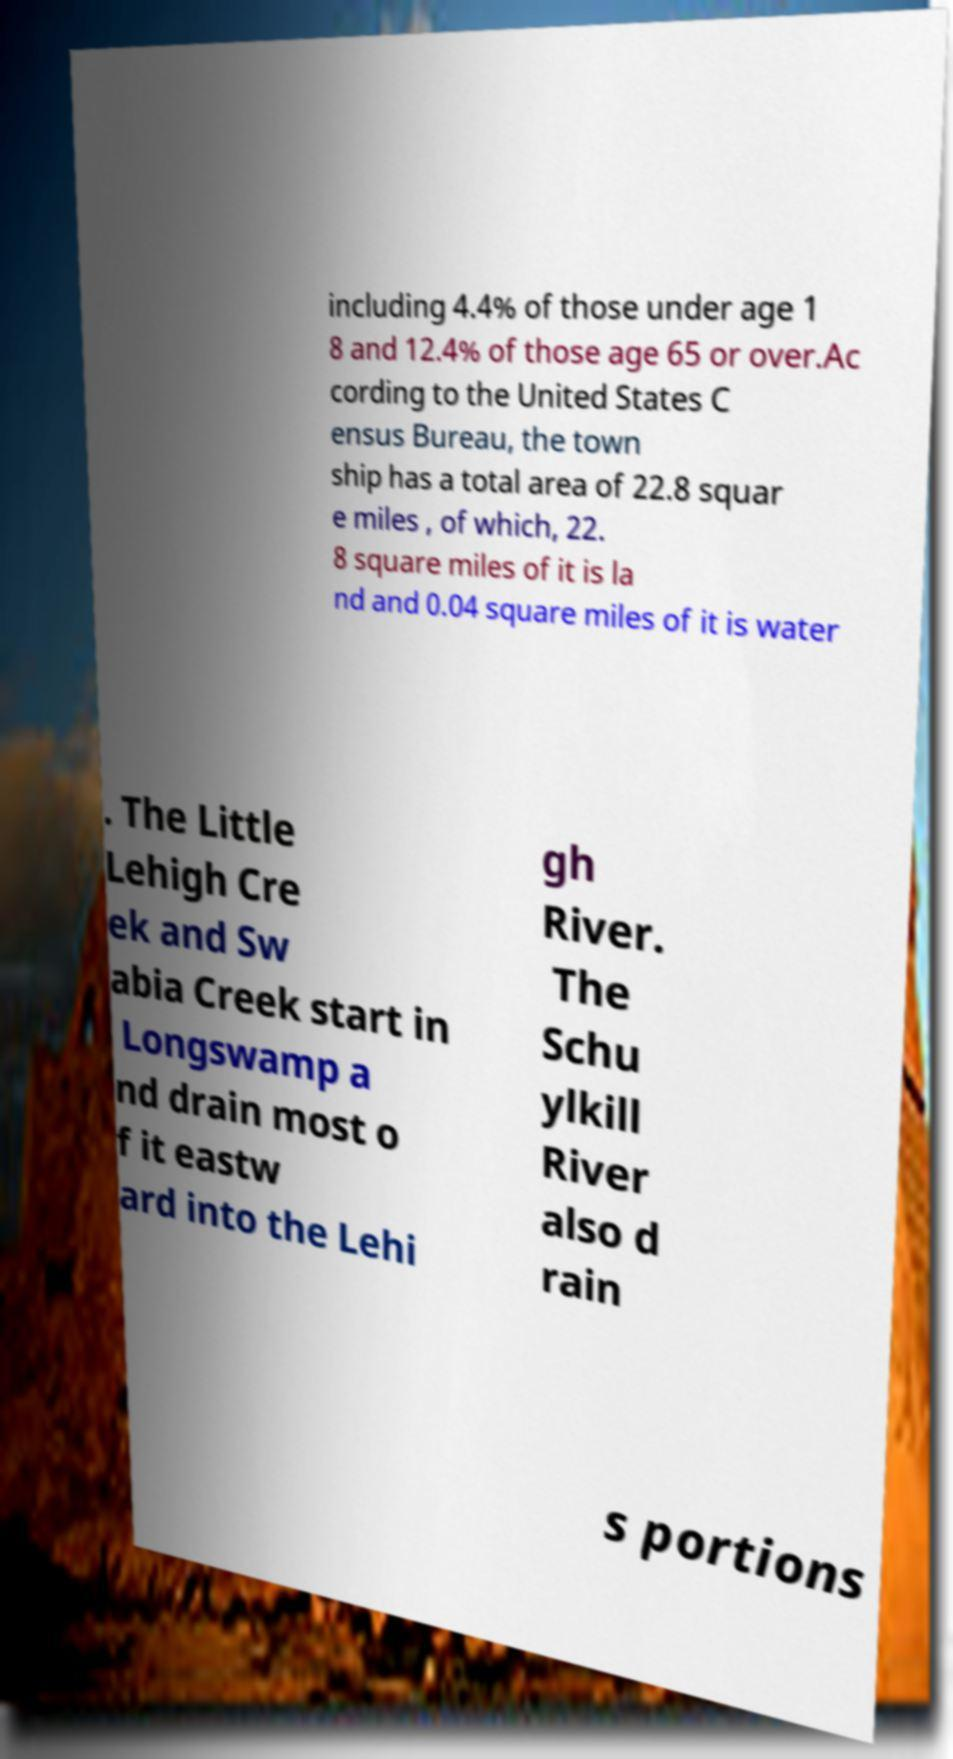Could you extract and type out the text from this image? including 4.4% of those under age 1 8 and 12.4% of those age 65 or over.Ac cording to the United States C ensus Bureau, the town ship has a total area of 22.8 squar e miles , of which, 22. 8 square miles of it is la nd and 0.04 square miles of it is water . The Little Lehigh Cre ek and Sw abia Creek start in Longswamp a nd drain most o f it eastw ard into the Lehi gh River. The Schu ylkill River also d rain s portions 